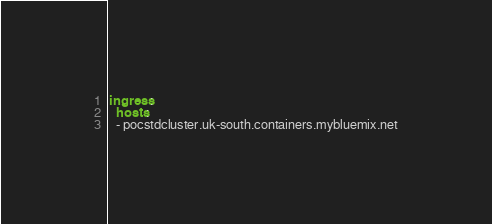<code> <loc_0><loc_0><loc_500><loc_500><_YAML_>ingress:
  hosts:
  - pocstdcluster.uk-south.containers.mybluemix.net
</code> 